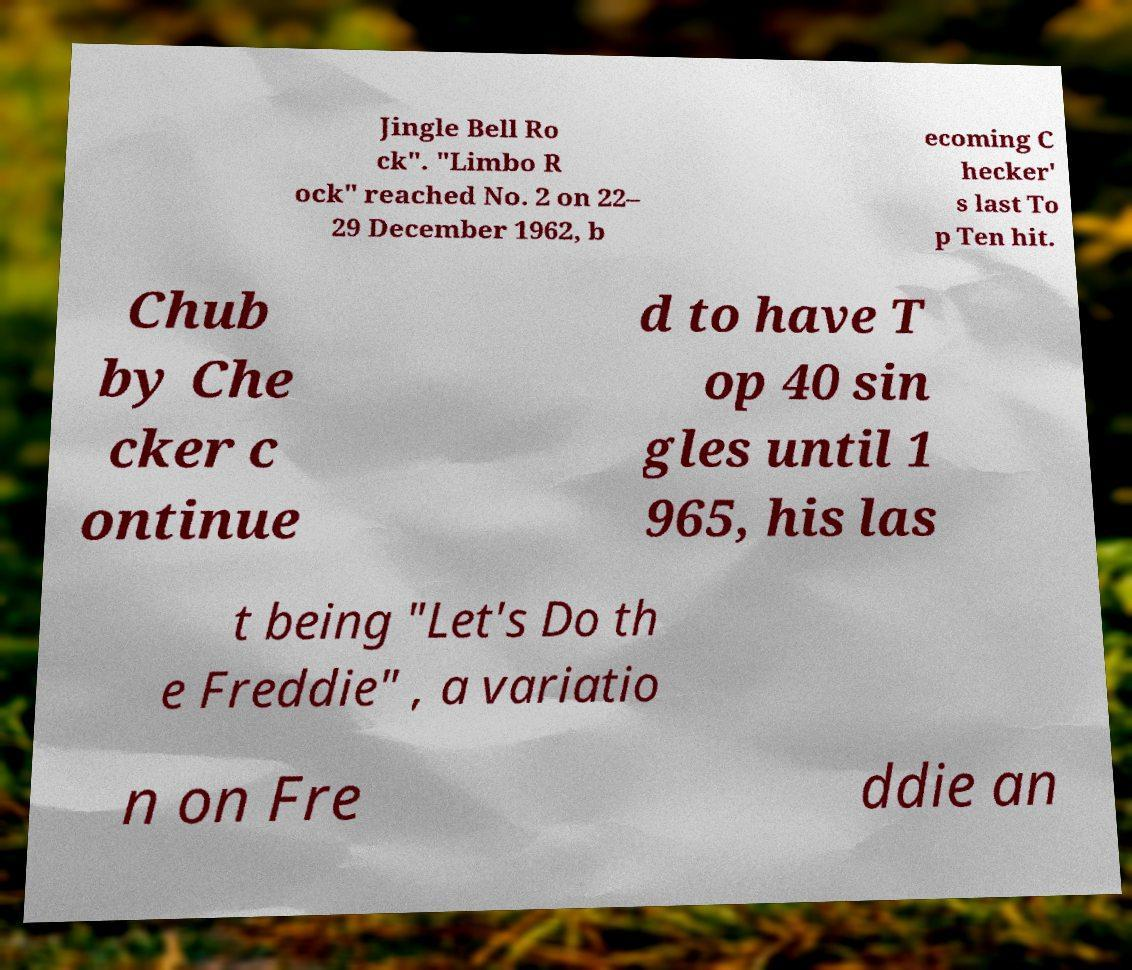Could you extract and type out the text from this image? Jingle Bell Ro ck". "Limbo R ock" reached No. 2 on 22– 29 December 1962, b ecoming C hecker' s last To p Ten hit. Chub by Che cker c ontinue d to have T op 40 sin gles until 1 965, his las t being "Let's Do th e Freddie" , a variatio n on Fre ddie an 